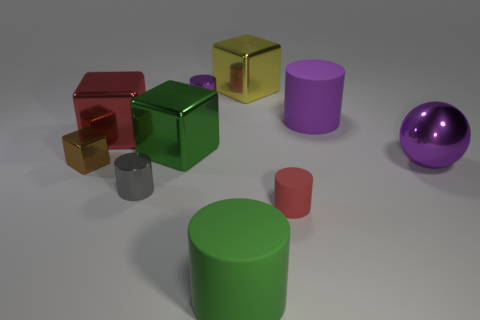What number of red objects are either small shiny blocks or small cylinders?
Offer a terse response. 1. How many other big objects have the same shape as the red metallic thing?
Your response must be concise. 2. What is the material of the green cylinder?
Give a very brief answer. Rubber. Are there the same number of small gray metal objects that are right of the purple matte cylinder and tiny yellow cylinders?
Provide a short and direct response. Yes. What shape is the purple rubber object that is the same size as the yellow shiny thing?
Offer a terse response. Cylinder. There is a large metal block on the left side of the tiny gray cylinder; is there a green metallic block that is left of it?
Your response must be concise. No. What number of small things are shiny spheres or brown objects?
Keep it short and to the point. 1. Is there a yellow block of the same size as the purple metal ball?
Make the answer very short. Yes. What number of metal objects are either cubes or gray things?
Keep it short and to the point. 5. What shape is the big thing that is the same color as the small rubber object?
Your response must be concise. Cube. 